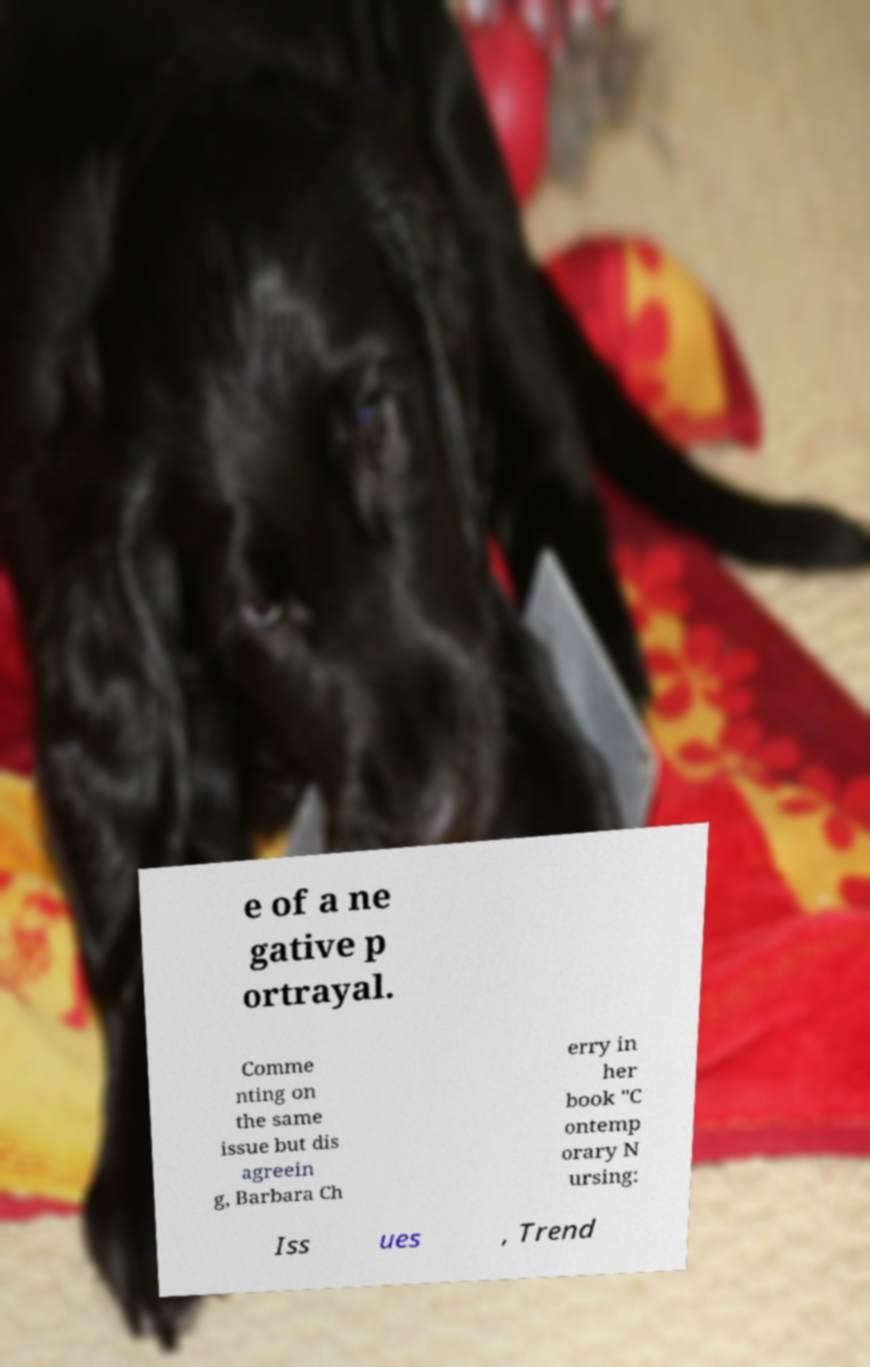I need the written content from this picture converted into text. Can you do that? e of a ne gative p ortrayal. Comme nting on the same issue but dis agreein g, Barbara Ch erry in her book "C ontemp orary N ursing: Iss ues , Trend 